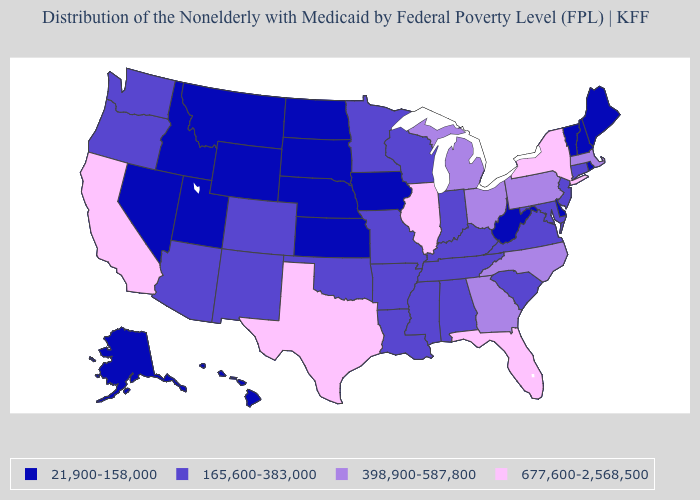What is the value of Alaska?
Keep it brief. 21,900-158,000. What is the highest value in states that border New York?
Short answer required. 398,900-587,800. Name the states that have a value in the range 165,600-383,000?
Concise answer only. Alabama, Arizona, Arkansas, Colorado, Connecticut, Indiana, Kentucky, Louisiana, Maryland, Minnesota, Mississippi, Missouri, New Jersey, New Mexico, Oklahoma, Oregon, South Carolina, Tennessee, Virginia, Washington, Wisconsin. Which states have the highest value in the USA?
Keep it brief. California, Florida, Illinois, New York, Texas. What is the value of Tennessee?
Keep it brief. 165,600-383,000. What is the value of Kansas?
Give a very brief answer. 21,900-158,000. Name the states that have a value in the range 677,600-2,568,500?
Keep it brief. California, Florida, Illinois, New York, Texas. Does Montana have the same value as Maine?
Answer briefly. Yes. What is the value of Idaho?
Short answer required. 21,900-158,000. Does Wisconsin have the lowest value in the MidWest?
Short answer required. No. Which states hav the highest value in the Northeast?
Short answer required. New York. Name the states that have a value in the range 165,600-383,000?
Write a very short answer. Alabama, Arizona, Arkansas, Colorado, Connecticut, Indiana, Kentucky, Louisiana, Maryland, Minnesota, Mississippi, Missouri, New Jersey, New Mexico, Oklahoma, Oregon, South Carolina, Tennessee, Virginia, Washington, Wisconsin. Among the states that border Georgia , does Alabama have the highest value?
Quick response, please. No. Name the states that have a value in the range 165,600-383,000?
Keep it brief. Alabama, Arizona, Arkansas, Colorado, Connecticut, Indiana, Kentucky, Louisiana, Maryland, Minnesota, Mississippi, Missouri, New Jersey, New Mexico, Oklahoma, Oregon, South Carolina, Tennessee, Virginia, Washington, Wisconsin. Name the states that have a value in the range 398,900-587,800?
Give a very brief answer. Georgia, Massachusetts, Michigan, North Carolina, Ohio, Pennsylvania. 